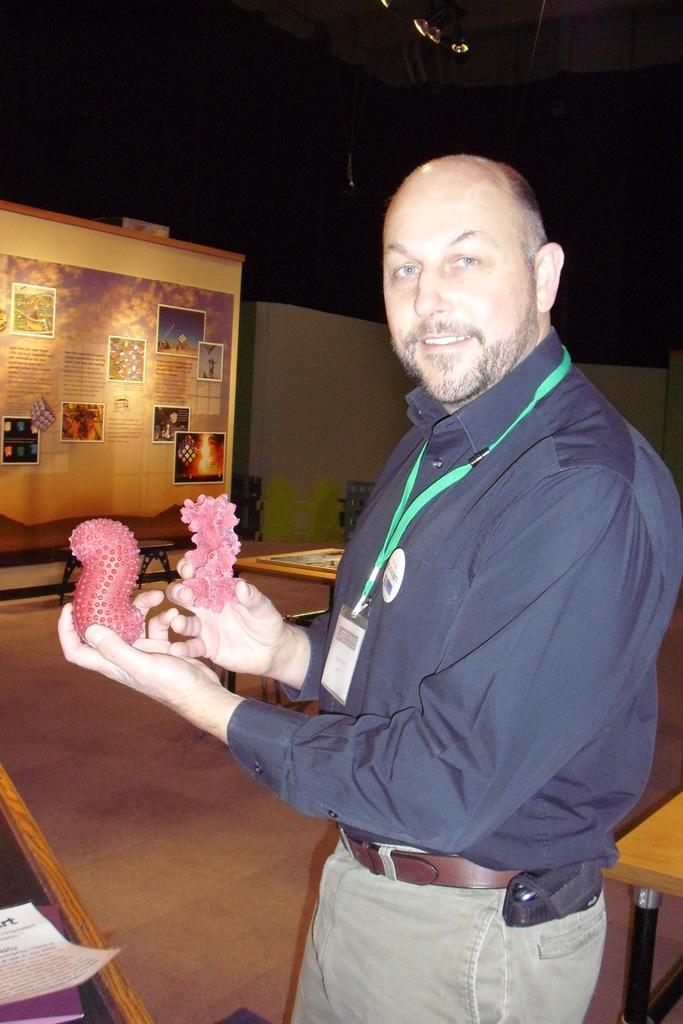What is the person in the image holding in their hands? There is a person holding objects in their hands in the image. What can be seen on the table in the image? There is a paper and a book on the table in the image. What is present on the board in the background? There are posts on a board in the background. What type of shoes is the person wearing in the image? There is no information about shoes in the image, as the focus is on the person holding objects and the items on the table and board. 